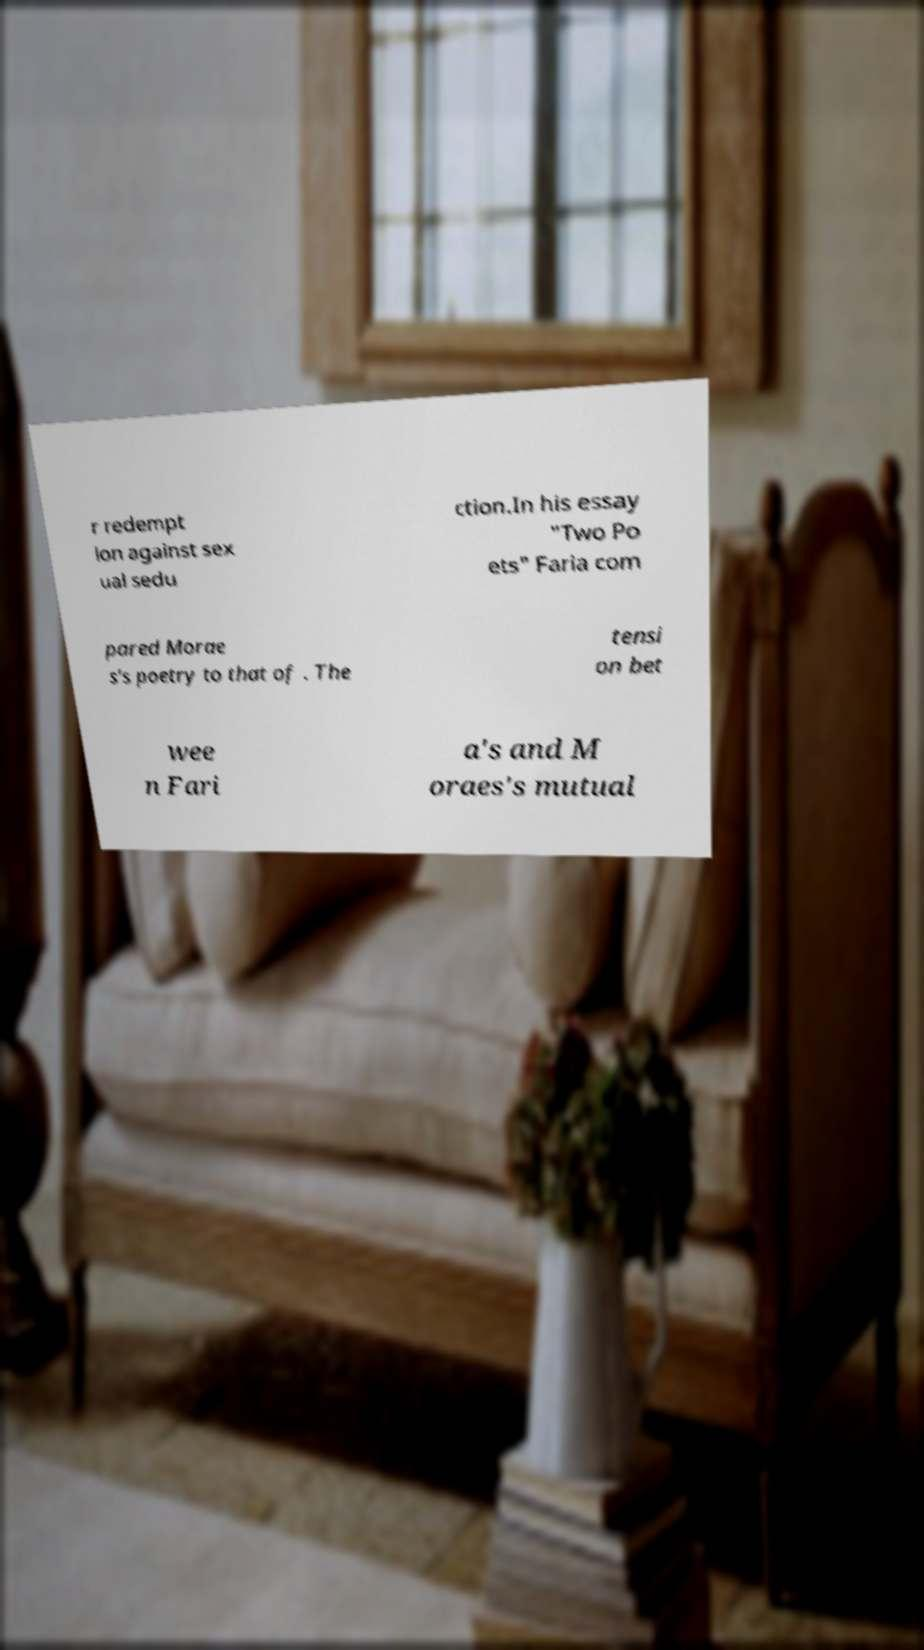What messages or text are displayed in this image? I need them in a readable, typed format. r redempt ion against sex ual sedu ction.In his essay "Two Po ets" Faria com pared Morae s's poetry to that of . The tensi on bet wee n Fari a's and M oraes's mutual 